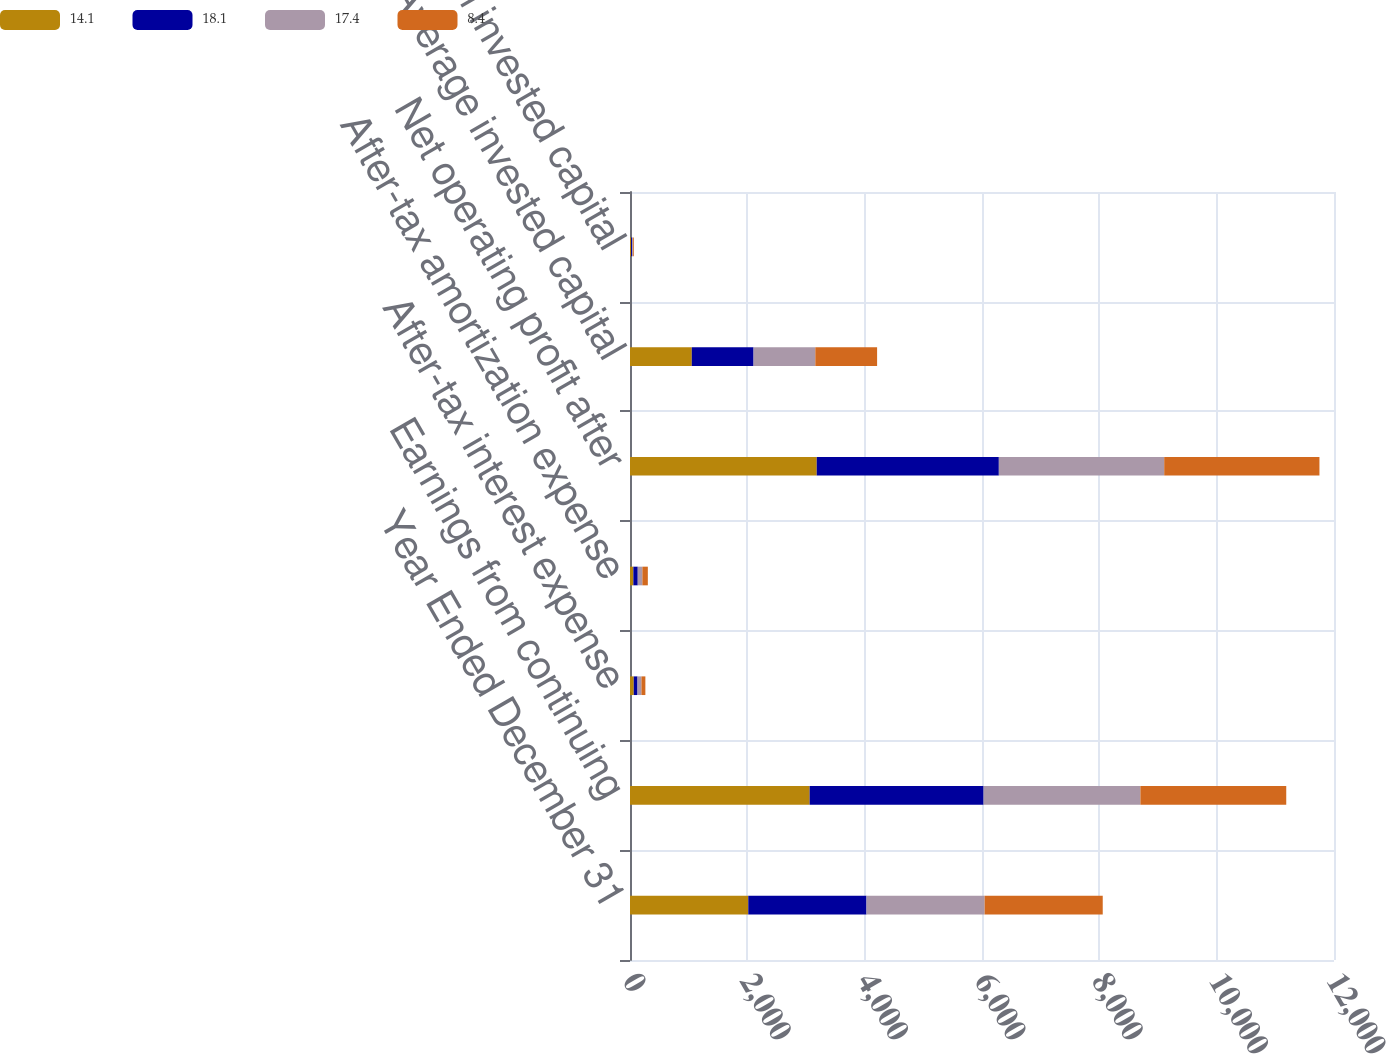Convert chart to OTSL. <chart><loc_0><loc_0><loc_500><loc_500><stacked_bar_chart><ecel><fcel>Year Ended December 31<fcel>Earnings from continuing<fcel>After-tax interest expense<fcel>After-tax amortization expense<fcel>Net operating profit after<fcel>Average invested capital<fcel>Return on invested capital<nl><fcel>14.1<fcel>2016<fcel>3062<fcel>64<fcel>57<fcel>3183<fcel>1053<fcel>18.1<nl><fcel>18.1<fcel>2015<fcel>2965<fcel>64<fcel>75<fcel>3104<fcel>1053<fcel>17.4<nl><fcel>17.4<fcel>2014<fcel>2673<fcel>67<fcel>79<fcel>2819<fcel>1053<fcel>15.1<nl><fcel>8.4<fcel>2013<fcel>2486<fcel>67<fcel>93<fcel>2646<fcel>1053<fcel>14.1<nl></chart> 